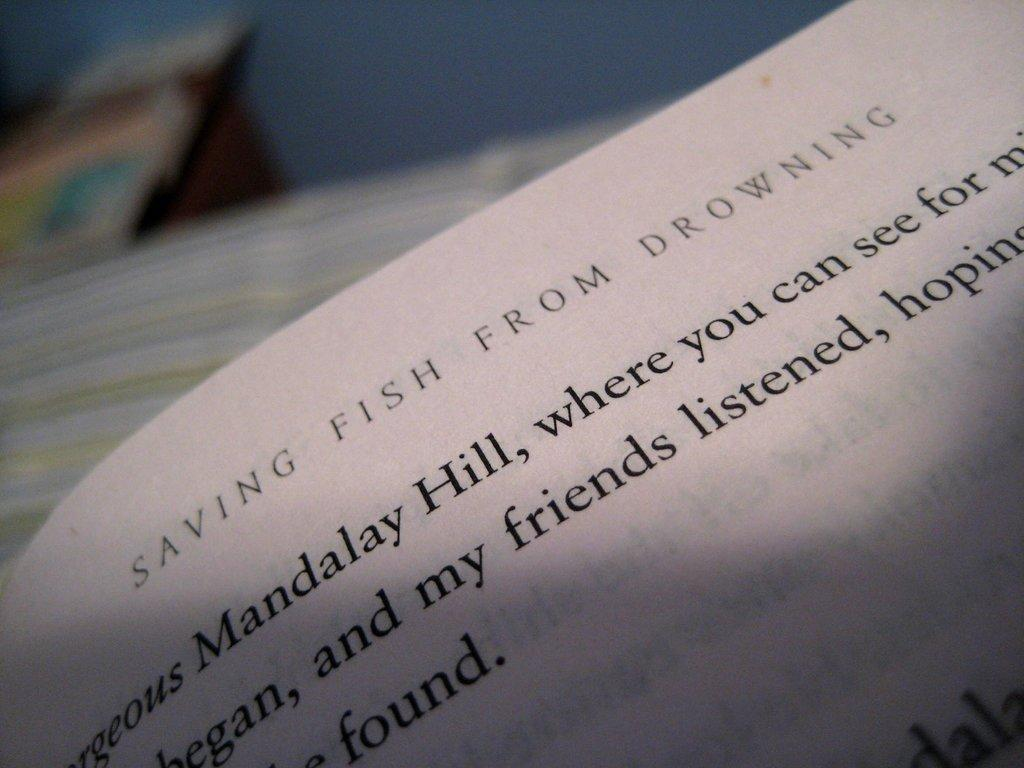<image>
Render a clear and concise summary of the photo. A page in a book called Saving Fish From Drowning mentions Mandalay Hill. 